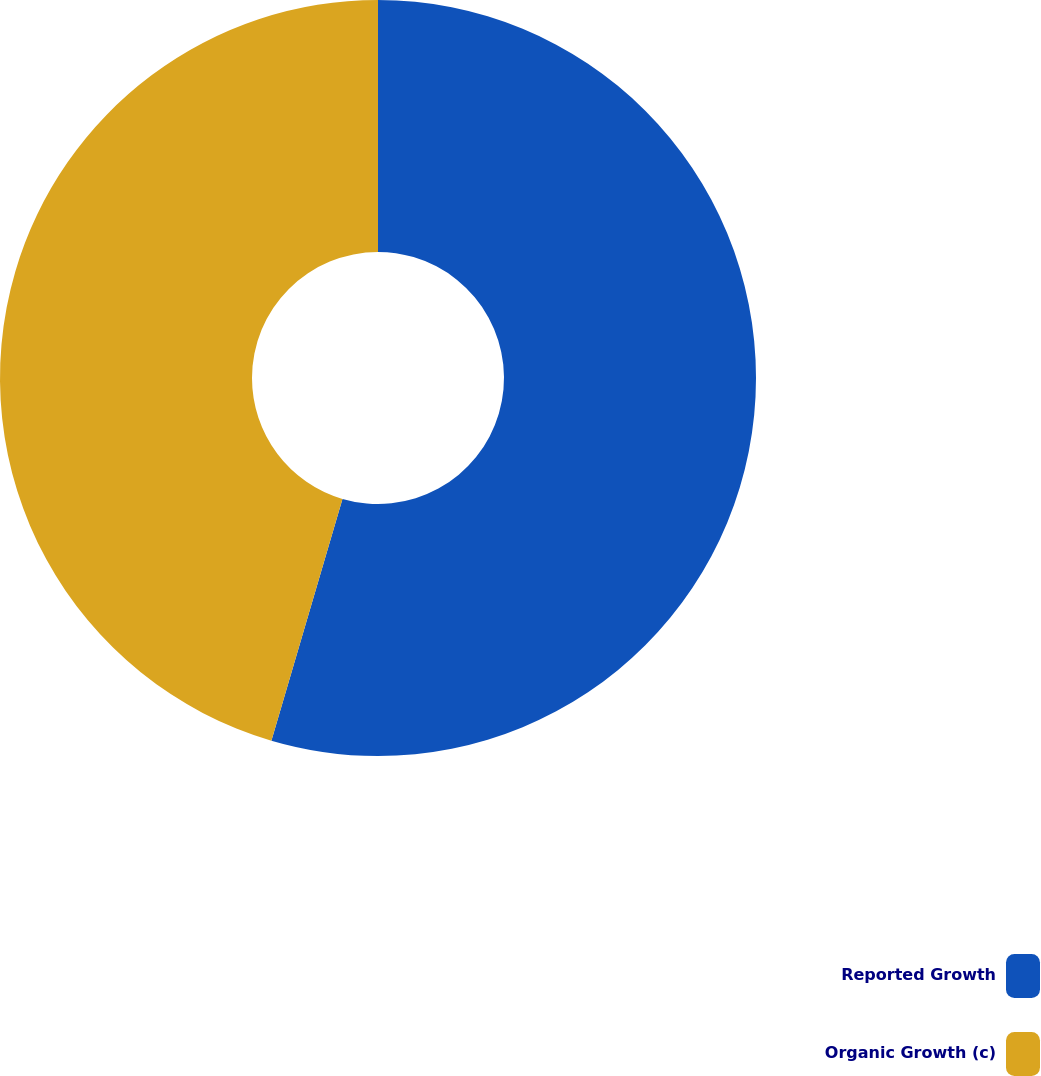<chart> <loc_0><loc_0><loc_500><loc_500><pie_chart><fcel>Reported Growth<fcel>Organic Growth (c)<nl><fcel>54.55%<fcel>45.45%<nl></chart> 